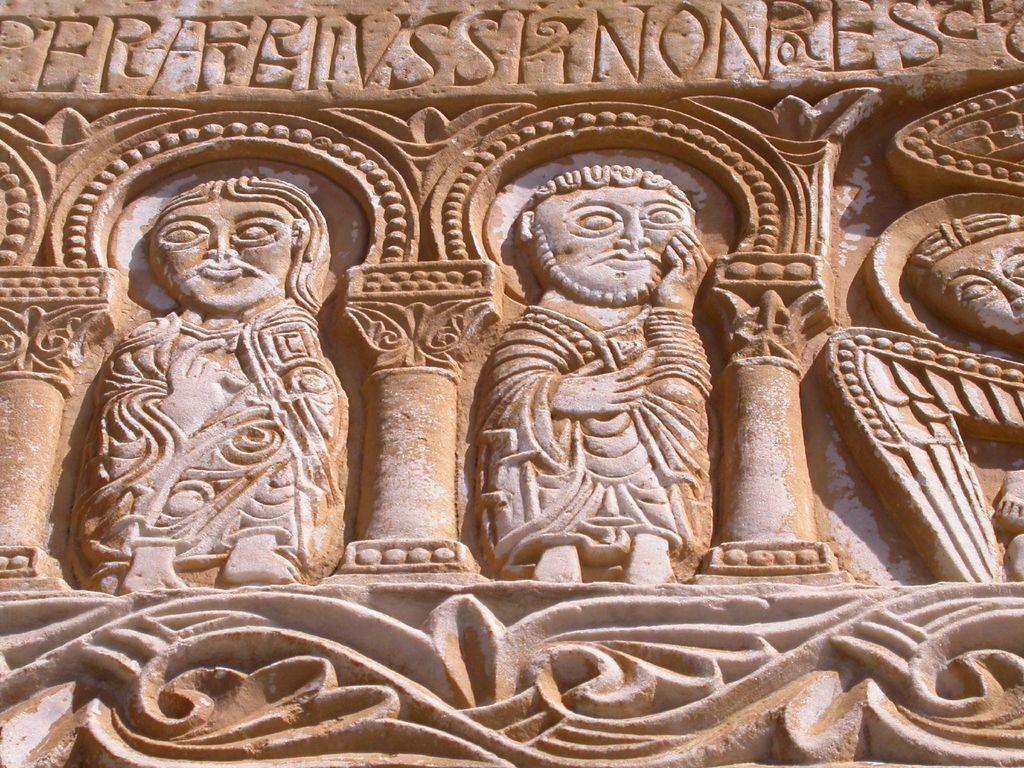What is the main subject of the image? The main subject of the image is a wood carving. Can you describe the colors of the wood carving? The wood carving is in brown and white colors. Is there any text present on the wood carving? Yes, there is text written on the wood carving. How many planes can be seen flying in the image? There are no planes visible in the image; it features a wood carving with text. Is there a person interacting with the wood carving in the image? There is no person present in the image; it only shows the wood carving with text. 